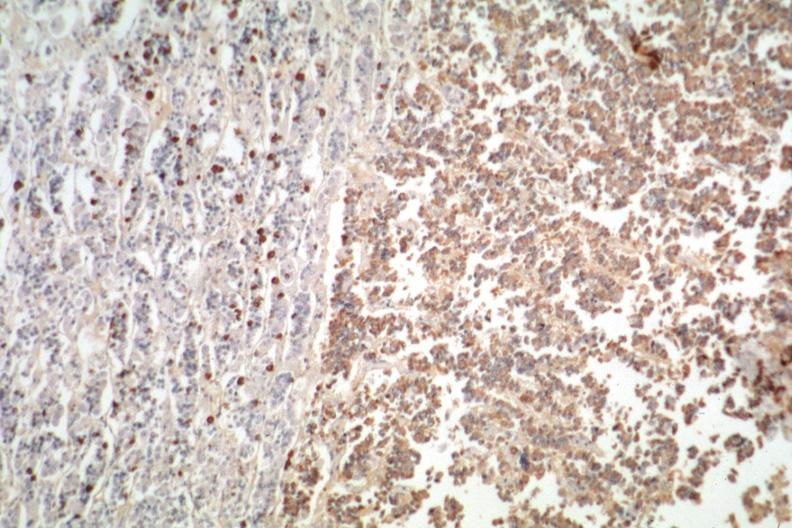what is present?
Answer the question using a single word or phrase. Endocrine 